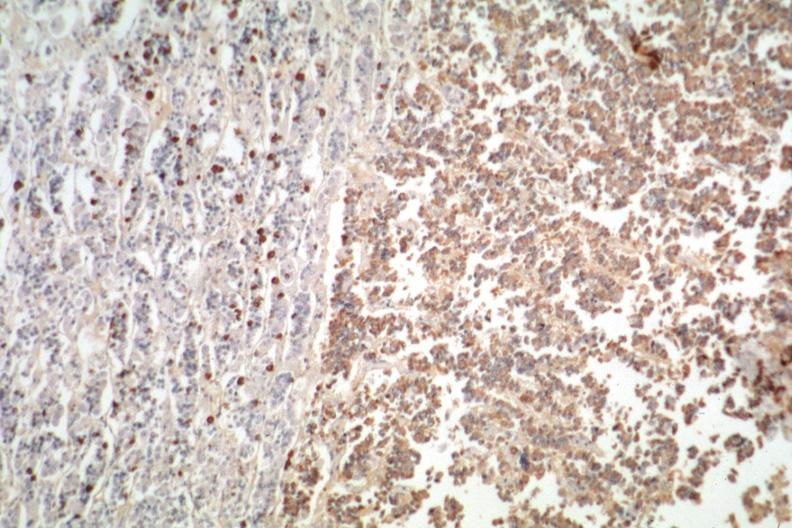what is present?
Answer the question using a single word or phrase. Endocrine 